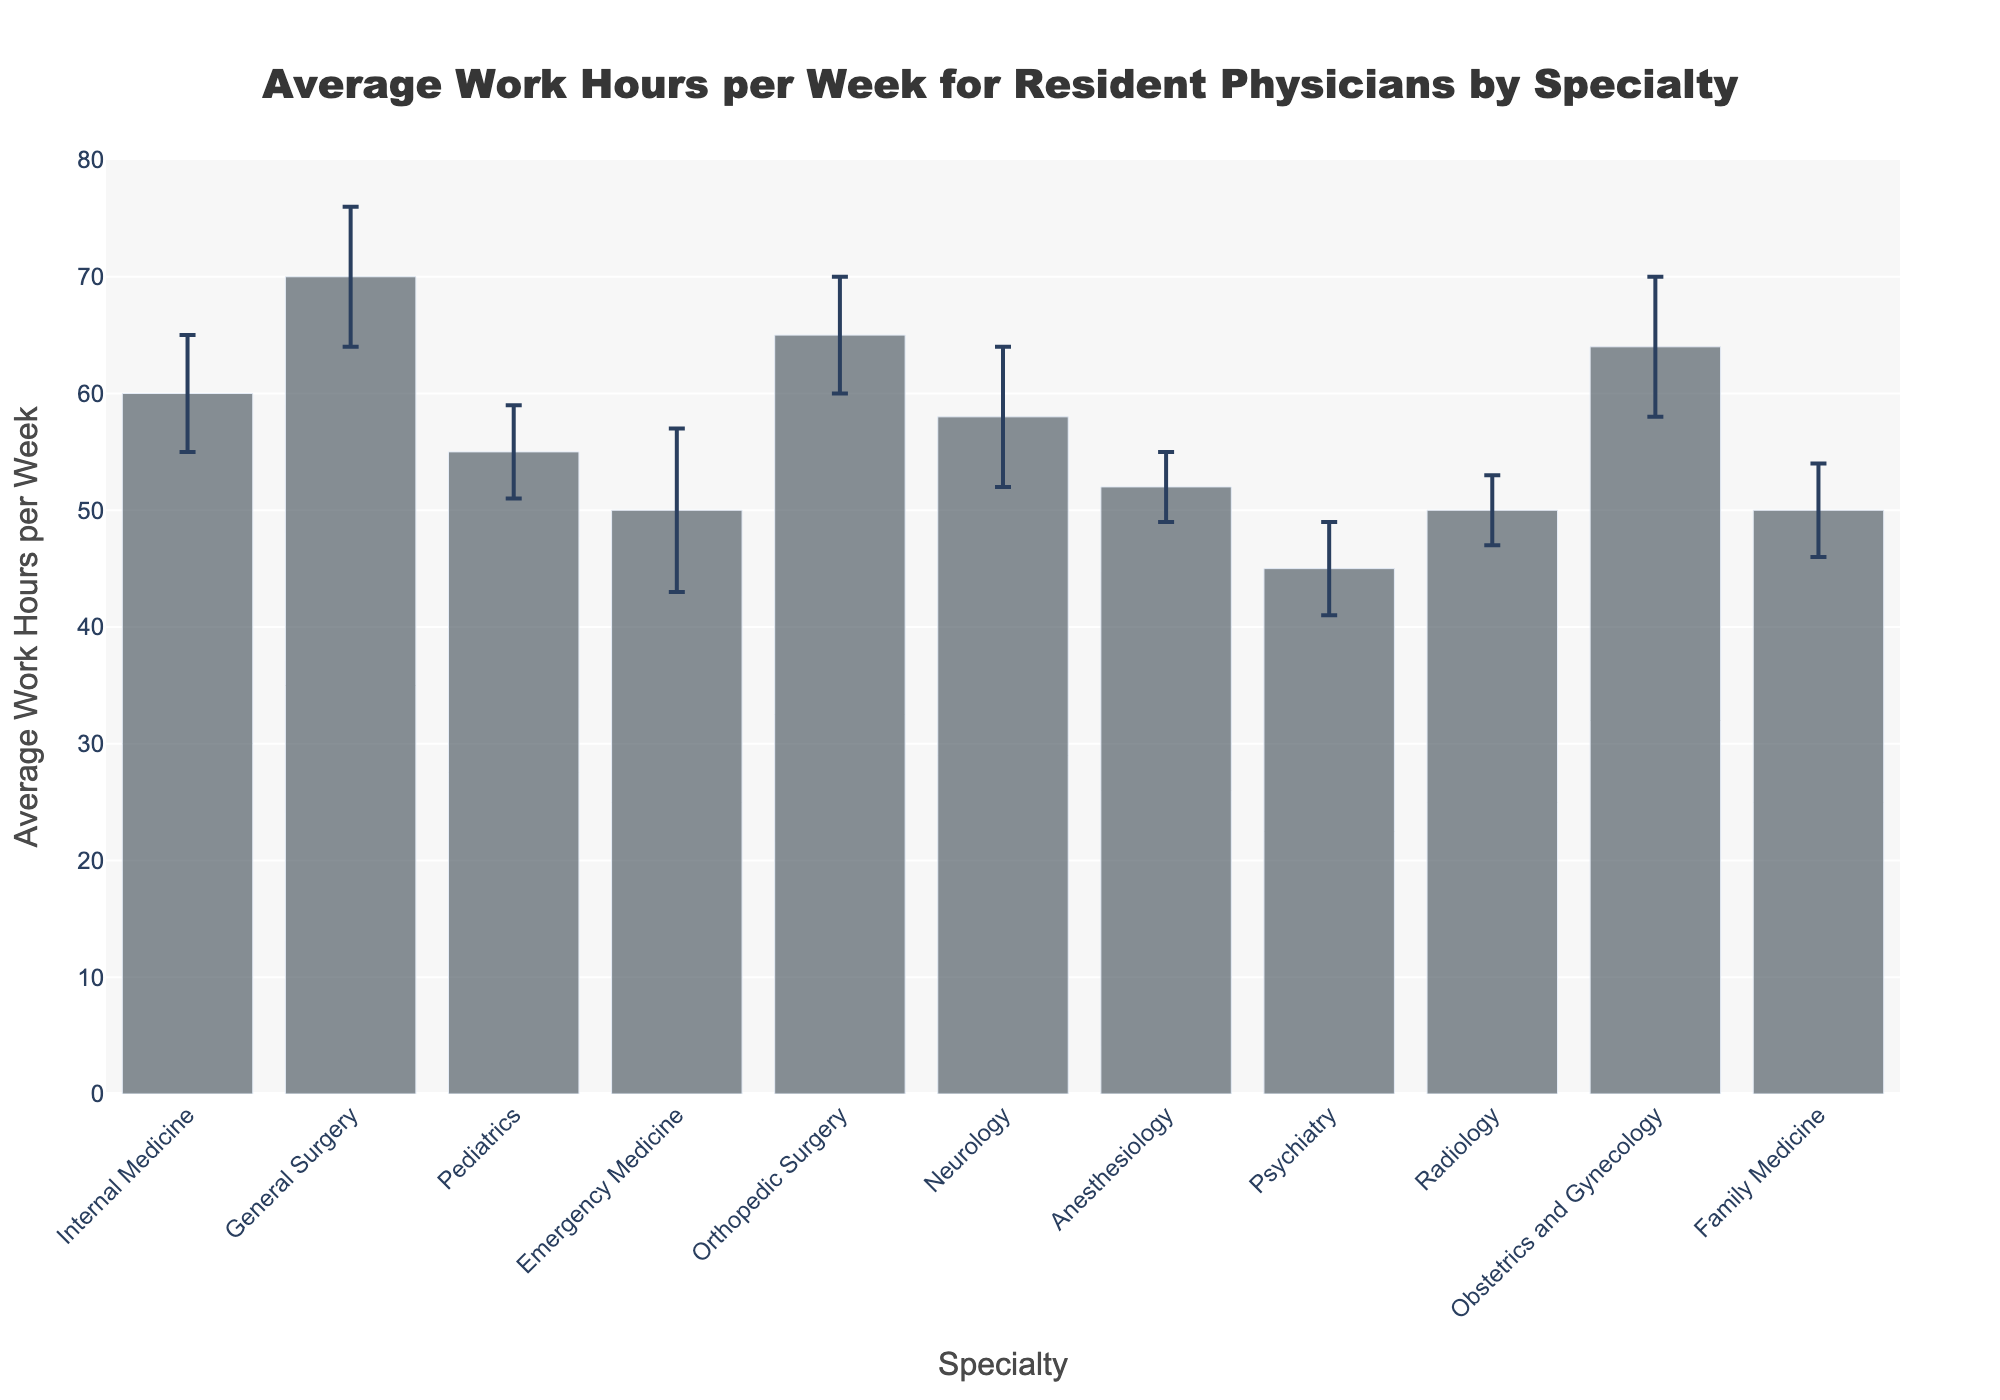What is the highest average work hours per week for a resident physician by specialty? The bar representing General Surgery reaches the highest point on the y-axis at 70 hours per week.
Answer: 70 hours per week Which specialty has the lowest average work hours per week? The bar for Psychiatry is the shortest on the y-axis, indicating it has the lowest average work hours at 45 hours per week.
Answer: Psychiatry What is the range of average work hours per week for the specialties shown? The highest average work hours is 70 for General Surgery and the lowest is 45 for Psychiatry. The range is 70 - 45.
Answer: 25 hours Which specialties have the same average work hours per week? The bars for Emergency Medicine, Radiology, and Family Medicine all reach the same height on the y-axis at 50 hours per week.
Answer: Emergency Medicine, Radiology, Family Medicine What is the difference in average work hours per week between Internal Medicine and Orthopedic Surgery? The average work hours for Internal Medicine is 60, while for Orthopedic Surgery it is 65. The difference is 65 - 60.
Answer: 5 hours Which specialties have an average work week of less than 55 hours? The bars for Psychiatry, Emergency Medicine, Radiology, Family Medicine, and Anesthesiology are all below 55 hours.
Answer: Psychiatry, Emergency Medicine, Radiology, Family Medicine, Anesthesiology What is the average work hours per week for Neurology, and what is its standard deviation? The Neurology bar is at 58 hours per week and the error bar indicates a standard deviation of 6.
Answer: 58 hours, 6 Does any specialty have a standard deviation in work hours greater than 7? The error bars for all specialties are examined, and only Emergency Medicine has a standard deviation of 7.
Answer: No Which specialty has the most variability in work hours per week? The longest error bar, which represents standard deviation, is for Emergency Medicine at 7.
Answer: Emergency Medicine How many specialties have average work hours per week above 60 hours? The bars above the 60-hour mark are those for General Surgery, Orthopedic Surgery, and Obstetrics and Gynecology.
Answer: 3 specialties 